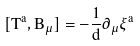<formula> <loc_0><loc_0><loc_500><loc_500>[ T ^ { a } , B _ { \mu } ] = - \frac { 1 } { d } \partial _ { \mu } \xi ^ { a }</formula> 